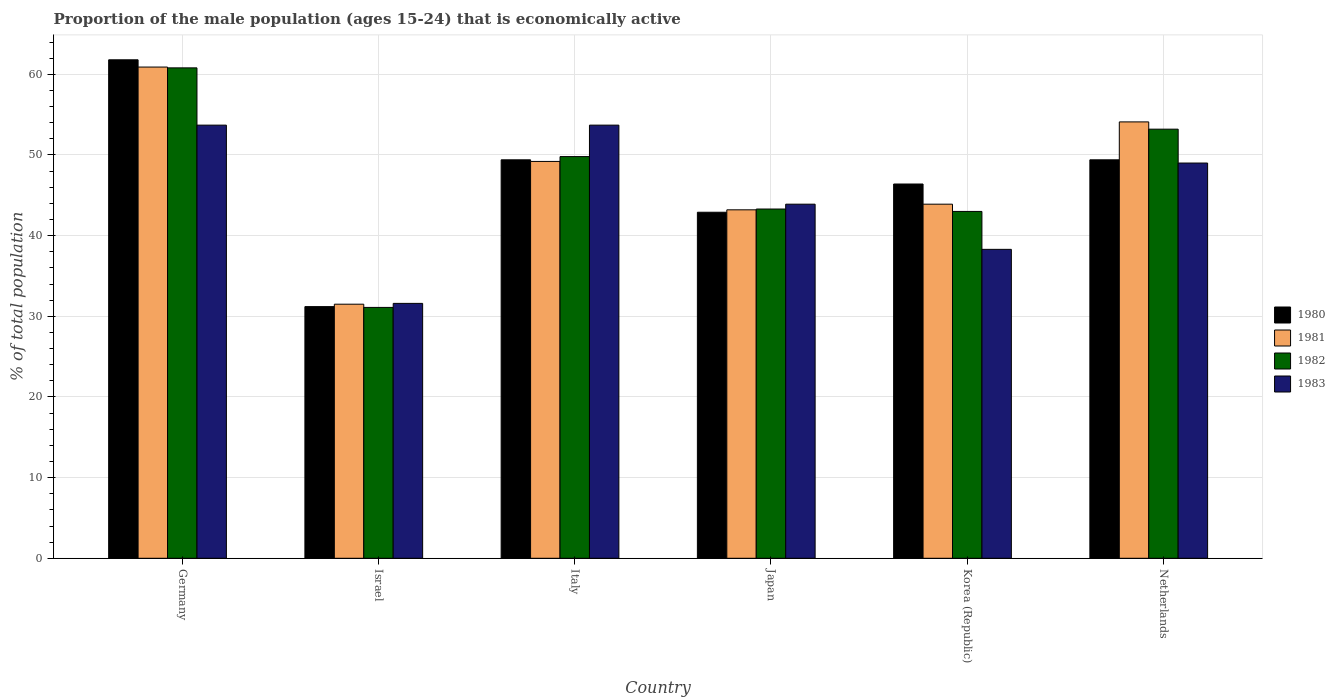Are the number of bars on each tick of the X-axis equal?
Offer a terse response. Yes. How many bars are there on the 2nd tick from the left?
Make the answer very short. 4. How many bars are there on the 2nd tick from the right?
Your response must be concise. 4. What is the label of the 2nd group of bars from the left?
Provide a succinct answer. Israel. In how many cases, is the number of bars for a given country not equal to the number of legend labels?
Provide a succinct answer. 0. What is the proportion of the male population that is economically active in 1982 in Germany?
Provide a succinct answer. 60.8. Across all countries, what is the maximum proportion of the male population that is economically active in 1983?
Provide a succinct answer. 53.7. Across all countries, what is the minimum proportion of the male population that is economically active in 1980?
Make the answer very short. 31.2. In which country was the proportion of the male population that is economically active in 1982 maximum?
Your answer should be very brief. Germany. In which country was the proportion of the male population that is economically active in 1982 minimum?
Ensure brevity in your answer.  Israel. What is the total proportion of the male population that is economically active in 1981 in the graph?
Keep it short and to the point. 282.8. What is the difference between the proportion of the male population that is economically active in 1983 in Germany and that in Netherlands?
Give a very brief answer. 4.7. What is the difference between the proportion of the male population that is economically active in 1981 in Netherlands and the proportion of the male population that is economically active in 1982 in Germany?
Provide a succinct answer. -6.7. What is the average proportion of the male population that is economically active in 1980 per country?
Ensure brevity in your answer.  46.85. What is the difference between the proportion of the male population that is economically active of/in 1981 and proportion of the male population that is economically active of/in 1983 in Germany?
Your answer should be compact. 7.2. In how many countries, is the proportion of the male population that is economically active in 1982 greater than 58 %?
Give a very brief answer. 1. What is the ratio of the proportion of the male population that is economically active in 1982 in Japan to that in Korea (Republic)?
Keep it short and to the point. 1.01. Is the proportion of the male population that is economically active in 1981 in Germany less than that in Korea (Republic)?
Your answer should be compact. No. Is the difference between the proportion of the male population that is economically active in 1981 in Israel and Korea (Republic) greater than the difference between the proportion of the male population that is economically active in 1983 in Israel and Korea (Republic)?
Offer a terse response. No. What is the difference between the highest and the second highest proportion of the male population that is economically active in 1981?
Your response must be concise. -11.7. What is the difference between the highest and the lowest proportion of the male population that is economically active in 1981?
Your response must be concise. 29.4. In how many countries, is the proportion of the male population that is economically active in 1981 greater than the average proportion of the male population that is economically active in 1981 taken over all countries?
Provide a succinct answer. 3. Is it the case that in every country, the sum of the proportion of the male population that is economically active in 1981 and proportion of the male population that is economically active in 1983 is greater than the sum of proportion of the male population that is economically active in 1980 and proportion of the male population that is economically active in 1982?
Offer a very short reply. No. What does the 2nd bar from the left in Japan represents?
Make the answer very short. 1981. What does the 1st bar from the right in Korea (Republic) represents?
Make the answer very short. 1983. Is it the case that in every country, the sum of the proportion of the male population that is economically active in 1983 and proportion of the male population that is economically active in 1982 is greater than the proportion of the male population that is economically active in 1981?
Your response must be concise. Yes. Are all the bars in the graph horizontal?
Offer a very short reply. No. What is the difference between two consecutive major ticks on the Y-axis?
Your response must be concise. 10. Does the graph contain any zero values?
Ensure brevity in your answer.  No. Does the graph contain grids?
Your answer should be very brief. Yes. How are the legend labels stacked?
Ensure brevity in your answer.  Vertical. What is the title of the graph?
Offer a very short reply. Proportion of the male population (ages 15-24) that is economically active. Does "1989" appear as one of the legend labels in the graph?
Offer a terse response. No. What is the label or title of the X-axis?
Provide a succinct answer. Country. What is the label or title of the Y-axis?
Your response must be concise. % of total population. What is the % of total population in 1980 in Germany?
Your response must be concise. 61.8. What is the % of total population of 1981 in Germany?
Ensure brevity in your answer.  60.9. What is the % of total population in 1982 in Germany?
Offer a very short reply. 60.8. What is the % of total population in 1983 in Germany?
Offer a terse response. 53.7. What is the % of total population in 1980 in Israel?
Your response must be concise. 31.2. What is the % of total population in 1981 in Israel?
Provide a succinct answer. 31.5. What is the % of total population in 1982 in Israel?
Your answer should be compact. 31.1. What is the % of total population of 1983 in Israel?
Ensure brevity in your answer.  31.6. What is the % of total population of 1980 in Italy?
Your answer should be compact. 49.4. What is the % of total population of 1981 in Italy?
Offer a terse response. 49.2. What is the % of total population of 1982 in Italy?
Your answer should be very brief. 49.8. What is the % of total population of 1983 in Italy?
Your answer should be compact. 53.7. What is the % of total population of 1980 in Japan?
Offer a very short reply. 42.9. What is the % of total population in 1981 in Japan?
Offer a very short reply. 43.2. What is the % of total population in 1982 in Japan?
Ensure brevity in your answer.  43.3. What is the % of total population of 1983 in Japan?
Make the answer very short. 43.9. What is the % of total population in 1980 in Korea (Republic)?
Offer a very short reply. 46.4. What is the % of total population in 1981 in Korea (Republic)?
Keep it short and to the point. 43.9. What is the % of total population in 1982 in Korea (Republic)?
Your answer should be compact. 43. What is the % of total population of 1983 in Korea (Republic)?
Provide a short and direct response. 38.3. What is the % of total population of 1980 in Netherlands?
Offer a very short reply. 49.4. What is the % of total population in 1981 in Netherlands?
Your response must be concise. 54.1. What is the % of total population in 1982 in Netherlands?
Make the answer very short. 53.2. Across all countries, what is the maximum % of total population of 1980?
Ensure brevity in your answer.  61.8. Across all countries, what is the maximum % of total population of 1981?
Ensure brevity in your answer.  60.9. Across all countries, what is the maximum % of total population of 1982?
Provide a short and direct response. 60.8. Across all countries, what is the maximum % of total population in 1983?
Give a very brief answer. 53.7. Across all countries, what is the minimum % of total population in 1980?
Your answer should be very brief. 31.2. Across all countries, what is the minimum % of total population in 1981?
Keep it short and to the point. 31.5. Across all countries, what is the minimum % of total population of 1982?
Ensure brevity in your answer.  31.1. Across all countries, what is the minimum % of total population of 1983?
Provide a succinct answer. 31.6. What is the total % of total population of 1980 in the graph?
Offer a very short reply. 281.1. What is the total % of total population in 1981 in the graph?
Offer a very short reply. 282.8. What is the total % of total population of 1982 in the graph?
Your answer should be very brief. 281.2. What is the total % of total population of 1983 in the graph?
Offer a terse response. 270.2. What is the difference between the % of total population of 1980 in Germany and that in Israel?
Make the answer very short. 30.6. What is the difference between the % of total population of 1981 in Germany and that in Israel?
Make the answer very short. 29.4. What is the difference between the % of total population of 1982 in Germany and that in Israel?
Provide a succinct answer. 29.7. What is the difference between the % of total population of 1983 in Germany and that in Israel?
Make the answer very short. 22.1. What is the difference between the % of total population in 1981 in Germany and that in Italy?
Provide a succinct answer. 11.7. What is the difference between the % of total population in 1982 in Germany and that in Italy?
Your response must be concise. 11. What is the difference between the % of total population in 1983 in Germany and that in Italy?
Provide a succinct answer. 0. What is the difference between the % of total population of 1983 in Germany and that in Japan?
Provide a succinct answer. 9.8. What is the difference between the % of total population of 1980 in Germany and that in Korea (Republic)?
Give a very brief answer. 15.4. What is the difference between the % of total population of 1982 in Germany and that in Korea (Republic)?
Provide a succinct answer. 17.8. What is the difference between the % of total population in 1983 in Germany and that in Korea (Republic)?
Offer a terse response. 15.4. What is the difference between the % of total population of 1980 in Germany and that in Netherlands?
Offer a terse response. 12.4. What is the difference between the % of total population of 1983 in Germany and that in Netherlands?
Offer a terse response. 4.7. What is the difference between the % of total population in 1980 in Israel and that in Italy?
Keep it short and to the point. -18.2. What is the difference between the % of total population in 1981 in Israel and that in Italy?
Provide a succinct answer. -17.7. What is the difference between the % of total population of 1982 in Israel and that in Italy?
Your answer should be compact. -18.7. What is the difference between the % of total population in 1983 in Israel and that in Italy?
Provide a succinct answer. -22.1. What is the difference between the % of total population in 1980 in Israel and that in Japan?
Keep it short and to the point. -11.7. What is the difference between the % of total population of 1981 in Israel and that in Japan?
Give a very brief answer. -11.7. What is the difference between the % of total population of 1983 in Israel and that in Japan?
Your answer should be very brief. -12.3. What is the difference between the % of total population in 1980 in Israel and that in Korea (Republic)?
Keep it short and to the point. -15.2. What is the difference between the % of total population in 1982 in Israel and that in Korea (Republic)?
Your answer should be compact. -11.9. What is the difference between the % of total population of 1980 in Israel and that in Netherlands?
Offer a very short reply. -18.2. What is the difference between the % of total population of 1981 in Israel and that in Netherlands?
Provide a short and direct response. -22.6. What is the difference between the % of total population of 1982 in Israel and that in Netherlands?
Your answer should be compact. -22.1. What is the difference between the % of total population of 1983 in Israel and that in Netherlands?
Offer a very short reply. -17.4. What is the difference between the % of total population in 1980 in Italy and that in Japan?
Ensure brevity in your answer.  6.5. What is the difference between the % of total population in 1983 in Italy and that in Japan?
Give a very brief answer. 9.8. What is the difference between the % of total population in 1981 in Italy and that in Korea (Republic)?
Ensure brevity in your answer.  5.3. What is the difference between the % of total population in 1982 in Italy and that in Korea (Republic)?
Provide a succinct answer. 6.8. What is the difference between the % of total population in 1981 in Japan and that in Korea (Republic)?
Offer a very short reply. -0.7. What is the difference between the % of total population in 1983 in Japan and that in Korea (Republic)?
Provide a short and direct response. 5.6. What is the difference between the % of total population of 1980 in Japan and that in Netherlands?
Offer a terse response. -6.5. What is the difference between the % of total population in 1982 in Japan and that in Netherlands?
Offer a terse response. -9.9. What is the difference between the % of total population of 1983 in Japan and that in Netherlands?
Your answer should be very brief. -5.1. What is the difference between the % of total population of 1983 in Korea (Republic) and that in Netherlands?
Offer a terse response. -10.7. What is the difference between the % of total population of 1980 in Germany and the % of total population of 1981 in Israel?
Your answer should be very brief. 30.3. What is the difference between the % of total population of 1980 in Germany and the % of total population of 1982 in Israel?
Keep it short and to the point. 30.7. What is the difference between the % of total population of 1980 in Germany and the % of total population of 1983 in Israel?
Your response must be concise. 30.2. What is the difference between the % of total population of 1981 in Germany and the % of total population of 1982 in Israel?
Offer a very short reply. 29.8. What is the difference between the % of total population in 1981 in Germany and the % of total population in 1983 in Israel?
Provide a short and direct response. 29.3. What is the difference between the % of total population of 1982 in Germany and the % of total population of 1983 in Israel?
Your answer should be very brief. 29.2. What is the difference between the % of total population in 1980 in Germany and the % of total population in 1982 in Italy?
Offer a very short reply. 12. What is the difference between the % of total population in 1980 in Germany and the % of total population in 1983 in Italy?
Make the answer very short. 8.1. What is the difference between the % of total population in 1981 in Germany and the % of total population in 1982 in Italy?
Your answer should be compact. 11.1. What is the difference between the % of total population in 1982 in Germany and the % of total population in 1983 in Italy?
Make the answer very short. 7.1. What is the difference between the % of total population of 1980 in Germany and the % of total population of 1981 in Japan?
Ensure brevity in your answer.  18.6. What is the difference between the % of total population of 1980 in Germany and the % of total population of 1982 in Japan?
Offer a very short reply. 18.5. What is the difference between the % of total population in 1980 in Germany and the % of total population in 1983 in Japan?
Your answer should be very brief. 17.9. What is the difference between the % of total population in 1982 in Germany and the % of total population in 1983 in Japan?
Your answer should be compact. 16.9. What is the difference between the % of total population in 1980 in Germany and the % of total population in 1981 in Korea (Republic)?
Make the answer very short. 17.9. What is the difference between the % of total population of 1981 in Germany and the % of total population of 1982 in Korea (Republic)?
Give a very brief answer. 17.9. What is the difference between the % of total population of 1981 in Germany and the % of total population of 1983 in Korea (Republic)?
Ensure brevity in your answer.  22.6. What is the difference between the % of total population in 1981 in Germany and the % of total population in 1982 in Netherlands?
Give a very brief answer. 7.7. What is the difference between the % of total population of 1981 in Germany and the % of total population of 1983 in Netherlands?
Your answer should be compact. 11.9. What is the difference between the % of total population in 1980 in Israel and the % of total population in 1982 in Italy?
Make the answer very short. -18.6. What is the difference between the % of total population in 1980 in Israel and the % of total population in 1983 in Italy?
Provide a short and direct response. -22.5. What is the difference between the % of total population of 1981 in Israel and the % of total population of 1982 in Italy?
Make the answer very short. -18.3. What is the difference between the % of total population of 1981 in Israel and the % of total population of 1983 in Italy?
Your response must be concise. -22.2. What is the difference between the % of total population in 1982 in Israel and the % of total population in 1983 in Italy?
Make the answer very short. -22.6. What is the difference between the % of total population in 1980 in Israel and the % of total population in 1981 in Japan?
Ensure brevity in your answer.  -12. What is the difference between the % of total population in 1981 in Israel and the % of total population in 1982 in Japan?
Provide a succinct answer. -11.8. What is the difference between the % of total population in 1981 in Israel and the % of total population in 1983 in Japan?
Offer a terse response. -12.4. What is the difference between the % of total population in 1980 in Israel and the % of total population in 1982 in Korea (Republic)?
Offer a terse response. -11.8. What is the difference between the % of total population in 1980 in Israel and the % of total population in 1983 in Korea (Republic)?
Offer a very short reply. -7.1. What is the difference between the % of total population of 1980 in Israel and the % of total population of 1981 in Netherlands?
Your answer should be compact. -22.9. What is the difference between the % of total population of 1980 in Israel and the % of total population of 1982 in Netherlands?
Keep it short and to the point. -22. What is the difference between the % of total population in 1980 in Israel and the % of total population in 1983 in Netherlands?
Your response must be concise. -17.8. What is the difference between the % of total population in 1981 in Israel and the % of total population in 1982 in Netherlands?
Your response must be concise. -21.7. What is the difference between the % of total population in 1981 in Israel and the % of total population in 1983 in Netherlands?
Provide a short and direct response. -17.5. What is the difference between the % of total population in 1982 in Israel and the % of total population in 1983 in Netherlands?
Offer a very short reply. -17.9. What is the difference between the % of total population of 1980 in Italy and the % of total population of 1983 in Japan?
Offer a terse response. 5.5. What is the difference between the % of total population in 1981 in Italy and the % of total population in 1982 in Japan?
Make the answer very short. 5.9. What is the difference between the % of total population in 1981 in Italy and the % of total population in 1983 in Japan?
Ensure brevity in your answer.  5.3. What is the difference between the % of total population of 1980 in Italy and the % of total population of 1982 in Korea (Republic)?
Keep it short and to the point. 6.4. What is the difference between the % of total population of 1980 in Italy and the % of total population of 1981 in Netherlands?
Provide a short and direct response. -4.7. What is the difference between the % of total population of 1980 in Italy and the % of total population of 1983 in Netherlands?
Your answer should be compact. 0.4. What is the difference between the % of total population in 1981 in Italy and the % of total population in 1983 in Netherlands?
Your answer should be very brief. 0.2. What is the difference between the % of total population in 1982 in Italy and the % of total population in 1983 in Netherlands?
Provide a short and direct response. 0.8. What is the difference between the % of total population of 1980 in Japan and the % of total population of 1981 in Korea (Republic)?
Your answer should be very brief. -1. What is the difference between the % of total population in 1980 in Japan and the % of total population in 1982 in Korea (Republic)?
Give a very brief answer. -0.1. What is the difference between the % of total population in 1980 in Japan and the % of total population in 1983 in Korea (Republic)?
Make the answer very short. 4.6. What is the difference between the % of total population in 1981 in Japan and the % of total population in 1983 in Korea (Republic)?
Provide a short and direct response. 4.9. What is the difference between the % of total population of 1982 in Japan and the % of total population of 1983 in Korea (Republic)?
Offer a very short reply. 5. What is the difference between the % of total population of 1980 in Japan and the % of total population of 1982 in Netherlands?
Keep it short and to the point. -10.3. What is the difference between the % of total population of 1980 in Japan and the % of total population of 1983 in Netherlands?
Keep it short and to the point. -6.1. What is the difference between the % of total population in 1981 in Japan and the % of total population in 1982 in Netherlands?
Provide a short and direct response. -10. What is the difference between the % of total population of 1982 in Japan and the % of total population of 1983 in Netherlands?
Your answer should be compact. -5.7. What is the difference between the % of total population in 1980 in Korea (Republic) and the % of total population in 1983 in Netherlands?
Offer a terse response. -2.6. What is the difference between the % of total population in 1981 in Korea (Republic) and the % of total population in 1983 in Netherlands?
Make the answer very short. -5.1. What is the average % of total population of 1980 per country?
Your answer should be very brief. 46.85. What is the average % of total population in 1981 per country?
Your answer should be very brief. 47.13. What is the average % of total population in 1982 per country?
Provide a short and direct response. 46.87. What is the average % of total population of 1983 per country?
Your answer should be very brief. 45.03. What is the difference between the % of total population in 1980 and % of total population in 1982 in Germany?
Your response must be concise. 1. What is the difference between the % of total population in 1981 and % of total population in 1982 in Germany?
Offer a terse response. 0.1. What is the difference between the % of total population in 1981 and % of total population in 1983 in Germany?
Offer a very short reply. 7.2. What is the difference between the % of total population of 1982 and % of total population of 1983 in Germany?
Provide a short and direct response. 7.1. What is the difference between the % of total population in 1980 and % of total population in 1981 in Israel?
Your response must be concise. -0.3. What is the difference between the % of total population of 1981 and % of total population of 1982 in Israel?
Ensure brevity in your answer.  0.4. What is the difference between the % of total population in 1981 and % of total population in 1982 in Italy?
Make the answer very short. -0.6. What is the difference between the % of total population of 1980 and % of total population of 1982 in Japan?
Make the answer very short. -0.4. What is the difference between the % of total population in 1981 and % of total population in 1983 in Japan?
Your answer should be compact. -0.7. What is the difference between the % of total population of 1980 and % of total population of 1982 in Korea (Republic)?
Make the answer very short. 3.4. What is the difference between the % of total population of 1980 and % of total population of 1983 in Korea (Republic)?
Make the answer very short. 8.1. What is the difference between the % of total population in 1981 and % of total population in 1983 in Korea (Republic)?
Provide a short and direct response. 5.6. What is the difference between the % of total population of 1982 and % of total population of 1983 in Korea (Republic)?
Provide a short and direct response. 4.7. What is the difference between the % of total population of 1980 and % of total population of 1981 in Netherlands?
Ensure brevity in your answer.  -4.7. What is the difference between the % of total population in 1980 and % of total population in 1982 in Netherlands?
Your response must be concise. -3.8. What is the difference between the % of total population of 1981 and % of total population of 1982 in Netherlands?
Make the answer very short. 0.9. What is the difference between the % of total population of 1981 and % of total population of 1983 in Netherlands?
Your answer should be very brief. 5.1. What is the difference between the % of total population of 1982 and % of total population of 1983 in Netherlands?
Provide a succinct answer. 4.2. What is the ratio of the % of total population in 1980 in Germany to that in Israel?
Make the answer very short. 1.98. What is the ratio of the % of total population of 1981 in Germany to that in Israel?
Provide a succinct answer. 1.93. What is the ratio of the % of total population in 1982 in Germany to that in Israel?
Ensure brevity in your answer.  1.96. What is the ratio of the % of total population in 1983 in Germany to that in Israel?
Keep it short and to the point. 1.7. What is the ratio of the % of total population of 1980 in Germany to that in Italy?
Provide a succinct answer. 1.25. What is the ratio of the % of total population in 1981 in Germany to that in Italy?
Offer a very short reply. 1.24. What is the ratio of the % of total population of 1982 in Germany to that in Italy?
Offer a terse response. 1.22. What is the ratio of the % of total population of 1980 in Germany to that in Japan?
Your response must be concise. 1.44. What is the ratio of the % of total population in 1981 in Germany to that in Japan?
Provide a short and direct response. 1.41. What is the ratio of the % of total population in 1982 in Germany to that in Japan?
Offer a terse response. 1.4. What is the ratio of the % of total population in 1983 in Germany to that in Japan?
Provide a succinct answer. 1.22. What is the ratio of the % of total population of 1980 in Germany to that in Korea (Republic)?
Offer a terse response. 1.33. What is the ratio of the % of total population of 1981 in Germany to that in Korea (Republic)?
Ensure brevity in your answer.  1.39. What is the ratio of the % of total population in 1982 in Germany to that in Korea (Republic)?
Offer a very short reply. 1.41. What is the ratio of the % of total population of 1983 in Germany to that in Korea (Republic)?
Make the answer very short. 1.4. What is the ratio of the % of total population of 1980 in Germany to that in Netherlands?
Offer a terse response. 1.25. What is the ratio of the % of total population of 1981 in Germany to that in Netherlands?
Your response must be concise. 1.13. What is the ratio of the % of total population in 1983 in Germany to that in Netherlands?
Make the answer very short. 1.1. What is the ratio of the % of total population in 1980 in Israel to that in Italy?
Make the answer very short. 0.63. What is the ratio of the % of total population of 1981 in Israel to that in Italy?
Give a very brief answer. 0.64. What is the ratio of the % of total population in 1982 in Israel to that in Italy?
Your answer should be compact. 0.62. What is the ratio of the % of total population of 1983 in Israel to that in Italy?
Offer a very short reply. 0.59. What is the ratio of the % of total population of 1980 in Israel to that in Japan?
Make the answer very short. 0.73. What is the ratio of the % of total population in 1981 in Israel to that in Japan?
Give a very brief answer. 0.73. What is the ratio of the % of total population in 1982 in Israel to that in Japan?
Your response must be concise. 0.72. What is the ratio of the % of total population in 1983 in Israel to that in Japan?
Provide a succinct answer. 0.72. What is the ratio of the % of total population of 1980 in Israel to that in Korea (Republic)?
Offer a very short reply. 0.67. What is the ratio of the % of total population of 1981 in Israel to that in Korea (Republic)?
Give a very brief answer. 0.72. What is the ratio of the % of total population of 1982 in Israel to that in Korea (Republic)?
Keep it short and to the point. 0.72. What is the ratio of the % of total population in 1983 in Israel to that in Korea (Republic)?
Ensure brevity in your answer.  0.83. What is the ratio of the % of total population of 1980 in Israel to that in Netherlands?
Offer a very short reply. 0.63. What is the ratio of the % of total population in 1981 in Israel to that in Netherlands?
Your answer should be compact. 0.58. What is the ratio of the % of total population in 1982 in Israel to that in Netherlands?
Give a very brief answer. 0.58. What is the ratio of the % of total population of 1983 in Israel to that in Netherlands?
Your answer should be compact. 0.64. What is the ratio of the % of total population in 1980 in Italy to that in Japan?
Give a very brief answer. 1.15. What is the ratio of the % of total population in 1981 in Italy to that in Japan?
Offer a terse response. 1.14. What is the ratio of the % of total population of 1982 in Italy to that in Japan?
Keep it short and to the point. 1.15. What is the ratio of the % of total population of 1983 in Italy to that in Japan?
Make the answer very short. 1.22. What is the ratio of the % of total population in 1980 in Italy to that in Korea (Republic)?
Offer a terse response. 1.06. What is the ratio of the % of total population in 1981 in Italy to that in Korea (Republic)?
Offer a very short reply. 1.12. What is the ratio of the % of total population of 1982 in Italy to that in Korea (Republic)?
Your answer should be compact. 1.16. What is the ratio of the % of total population of 1983 in Italy to that in Korea (Republic)?
Provide a short and direct response. 1.4. What is the ratio of the % of total population in 1980 in Italy to that in Netherlands?
Make the answer very short. 1. What is the ratio of the % of total population in 1981 in Italy to that in Netherlands?
Make the answer very short. 0.91. What is the ratio of the % of total population of 1982 in Italy to that in Netherlands?
Your answer should be compact. 0.94. What is the ratio of the % of total population of 1983 in Italy to that in Netherlands?
Your answer should be compact. 1.1. What is the ratio of the % of total population of 1980 in Japan to that in Korea (Republic)?
Your answer should be compact. 0.92. What is the ratio of the % of total population in 1981 in Japan to that in Korea (Republic)?
Your answer should be compact. 0.98. What is the ratio of the % of total population of 1982 in Japan to that in Korea (Republic)?
Provide a succinct answer. 1.01. What is the ratio of the % of total population in 1983 in Japan to that in Korea (Republic)?
Provide a short and direct response. 1.15. What is the ratio of the % of total population in 1980 in Japan to that in Netherlands?
Provide a short and direct response. 0.87. What is the ratio of the % of total population in 1981 in Japan to that in Netherlands?
Give a very brief answer. 0.8. What is the ratio of the % of total population in 1982 in Japan to that in Netherlands?
Give a very brief answer. 0.81. What is the ratio of the % of total population of 1983 in Japan to that in Netherlands?
Your answer should be compact. 0.9. What is the ratio of the % of total population of 1980 in Korea (Republic) to that in Netherlands?
Ensure brevity in your answer.  0.94. What is the ratio of the % of total population in 1981 in Korea (Republic) to that in Netherlands?
Your answer should be compact. 0.81. What is the ratio of the % of total population of 1982 in Korea (Republic) to that in Netherlands?
Your answer should be compact. 0.81. What is the ratio of the % of total population in 1983 in Korea (Republic) to that in Netherlands?
Ensure brevity in your answer.  0.78. What is the difference between the highest and the second highest % of total population of 1980?
Give a very brief answer. 12.4. What is the difference between the highest and the second highest % of total population of 1981?
Provide a short and direct response. 6.8. What is the difference between the highest and the second highest % of total population in 1982?
Provide a short and direct response. 7.6. What is the difference between the highest and the second highest % of total population in 1983?
Ensure brevity in your answer.  0. What is the difference between the highest and the lowest % of total population of 1980?
Provide a succinct answer. 30.6. What is the difference between the highest and the lowest % of total population of 1981?
Provide a succinct answer. 29.4. What is the difference between the highest and the lowest % of total population of 1982?
Offer a very short reply. 29.7. What is the difference between the highest and the lowest % of total population in 1983?
Ensure brevity in your answer.  22.1. 